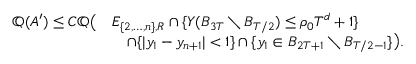Convert formula to latex. <formula><loc_0><loc_0><loc_500><loc_500>\begin{array} { r l } { \mathbb { Q } ( A ^ { \prime } ) \leq C \mathbb { Q } \left ( } & { E _ { \{ 2 , \dots , n \} , R } \cap \{ Y ( B _ { 3 T } \ B _ { T / 2 } ) \leq \rho _ { 0 } T ^ { d } + 1 \} } \\ & { \quad \cap \{ | y _ { 1 } - y _ { n + 1 } | < 1 \} \cap \{ y _ { 1 } \in B _ { 2 T + 1 } \ B _ { T / 2 - 1 } \} \right ) . } \end{array}</formula> 